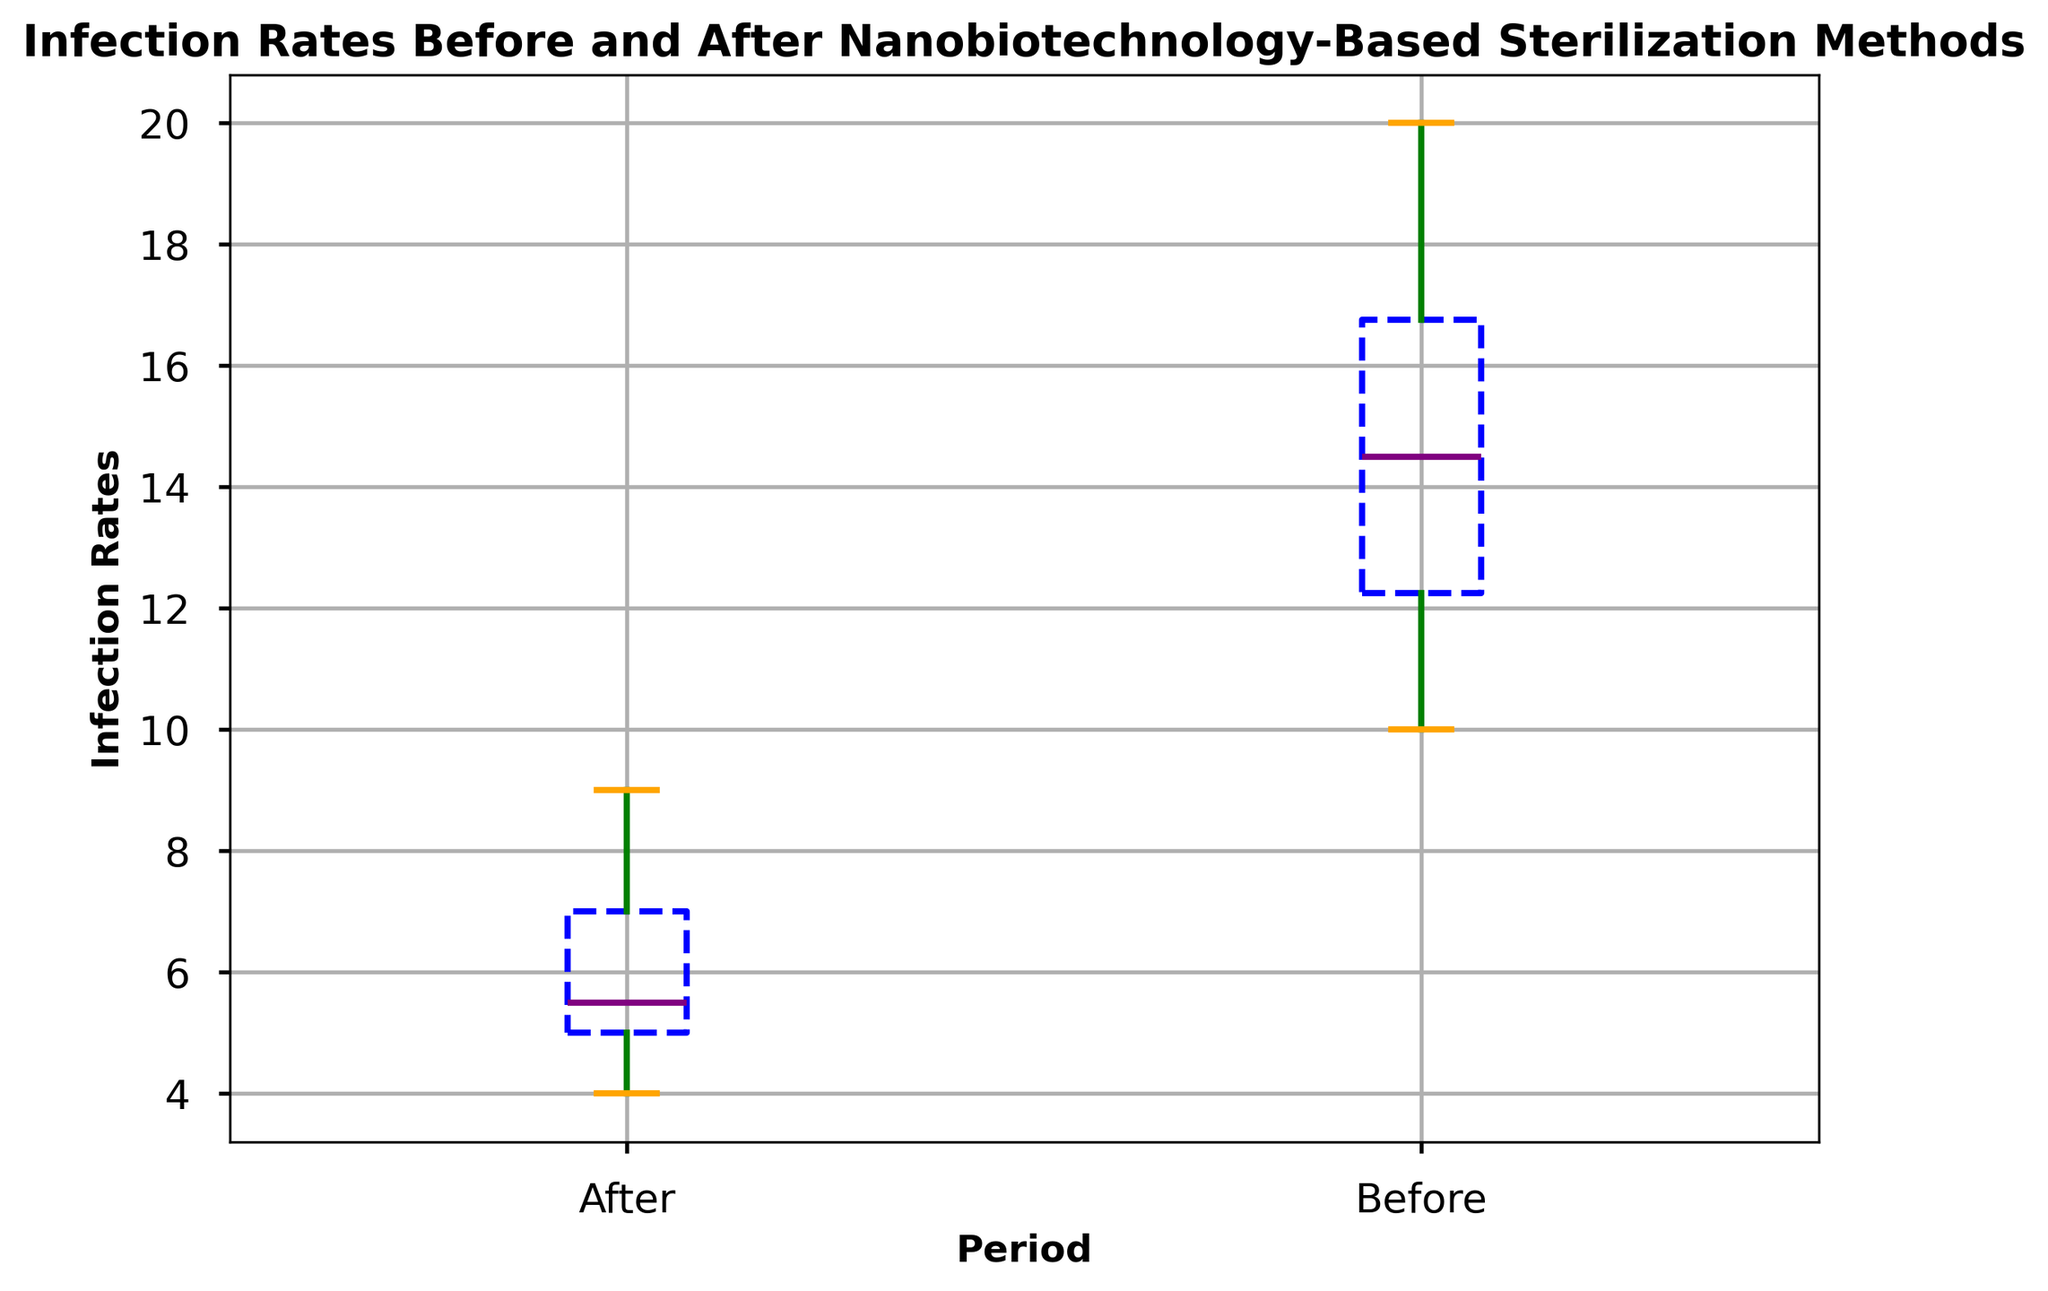What is the median infection rate before the implementation of the nanobiotechnology-based sterilization methods? To find the median infection rate before implementation, look at the plot's "Before" box plot and identify the purple horizontal line within it, which represents the median of the dataset.
Answer: 14 After the implementation of nanobiotechnology-based sterilization methods, is the median infection rate higher or lower compared to the period before implementation? Compare the median lines (purple) of both "Before" and "After" box plots. The median for "After" is lower than the median for "Before".
Answer: Lower What is the interquartile range (IQR) of the infection rates after the implementation? The IQR is the difference between the upper quartile (Q3) and the lower quartile (Q1). In the "After" box plot, identify these quartile values using the top and bottom of the blue box. Calculate IQR = Q3 - Q1.
Answer: 2 (i.e., Q3=7 and Q1=5) How does the range of infection rates before implementation compare to the range after implementation? The range is calculated from the whiskers in the box plots. For "Before," identify the highest and lowest points (20 and 10). For "After," do the same (9 and 4). Compare the ranges.
Answer: Before: 10, After: 5 Which group has more outliers, "Before" or "After"? Outliers are represented by red circles outside the whiskers. Count the outliers in "Before" and "After" box plots.
Answer: Before What color represents the whiskers in the box plot? Focus on the color of the lines extending from the top and bottom of the boxes. The color is green.
Answer: green By how much did the median infection rate decrease after the implementation? Identify the median values in both "Before" and "After" box plots (14 and 6.5, respectively). Subtract the "After" median from the "Before" median.
Answer: 7.5 What can you infer about the variation in infection rates before and after implementation based on the box plots? Assess the spread of the data indicated by the length of the boxes and whiskers. A larger spread suggests more variation, and a smaller spread suggests less variation.
Answer: Variation decreased Which period shows a greater consistency in infection rates? Consistency corresponds to a smaller spread in the box plot. Compare the length of the interquartile ranges (boxes) and whiskers of "Before" and "After."
Answer: After 